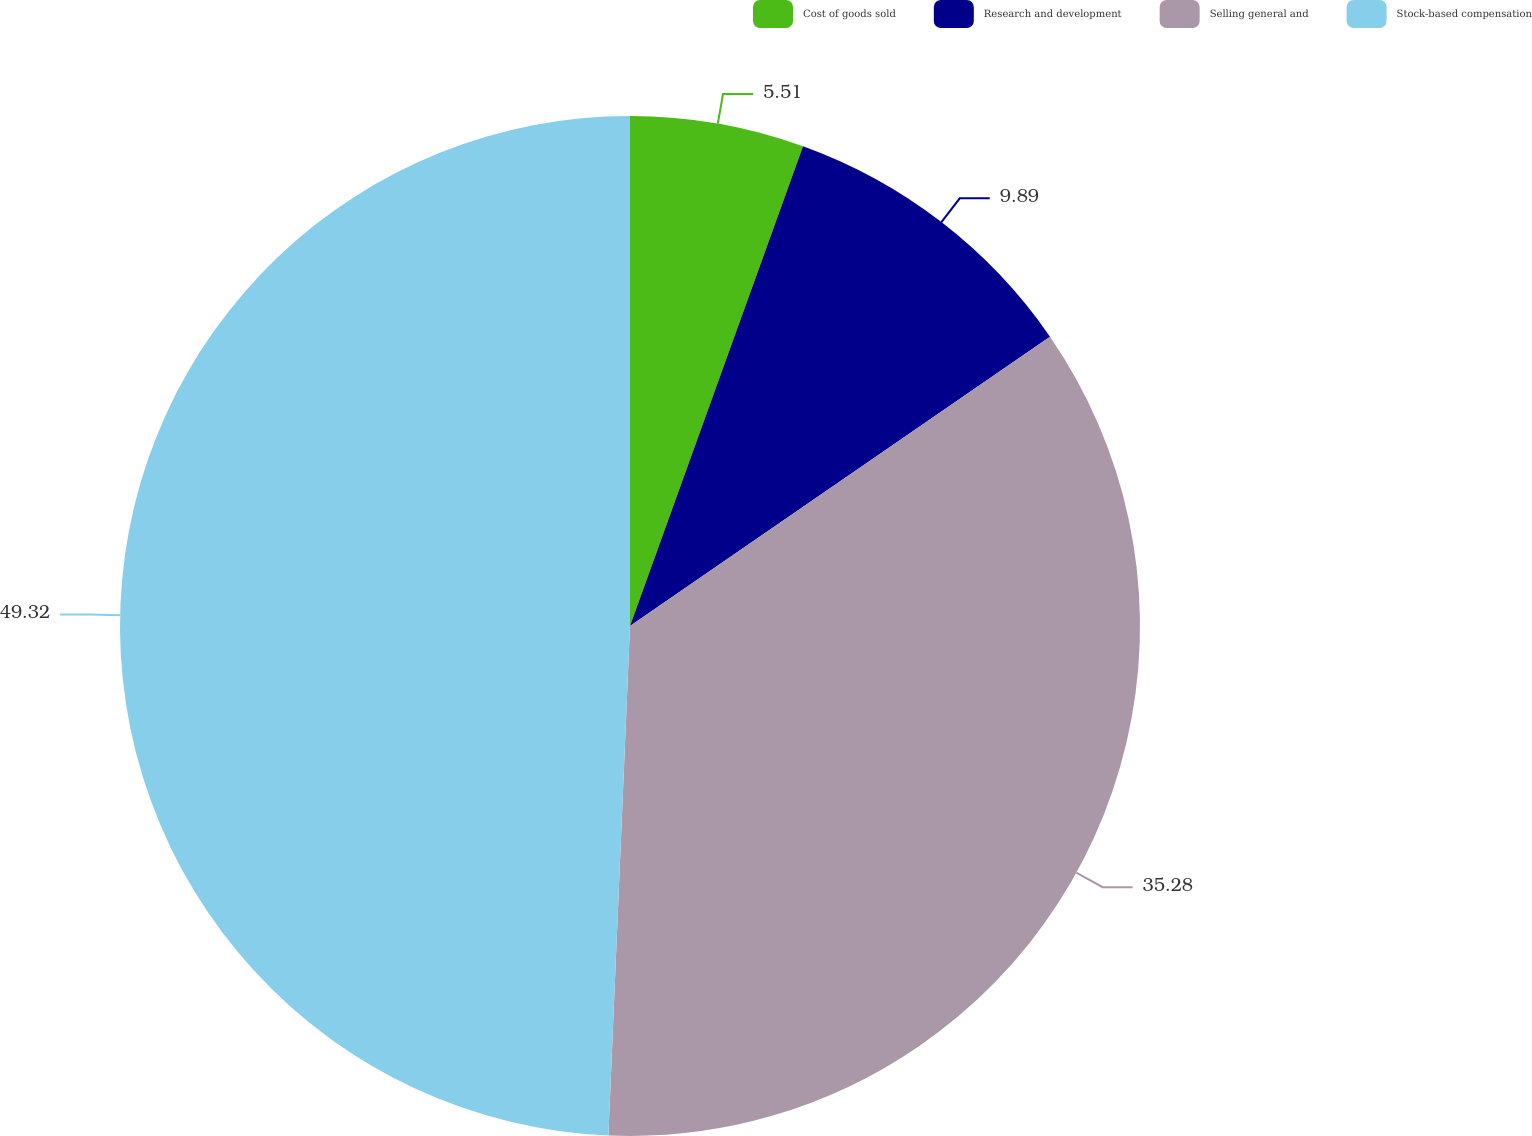Convert chart to OTSL. <chart><loc_0><loc_0><loc_500><loc_500><pie_chart><fcel>Cost of goods sold<fcel>Research and development<fcel>Selling general and<fcel>Stock-based compensation<nl><fcel>5.51%<fcel>9.89%<fcel>35.28%<fcel>49.33%<nl></chart> 